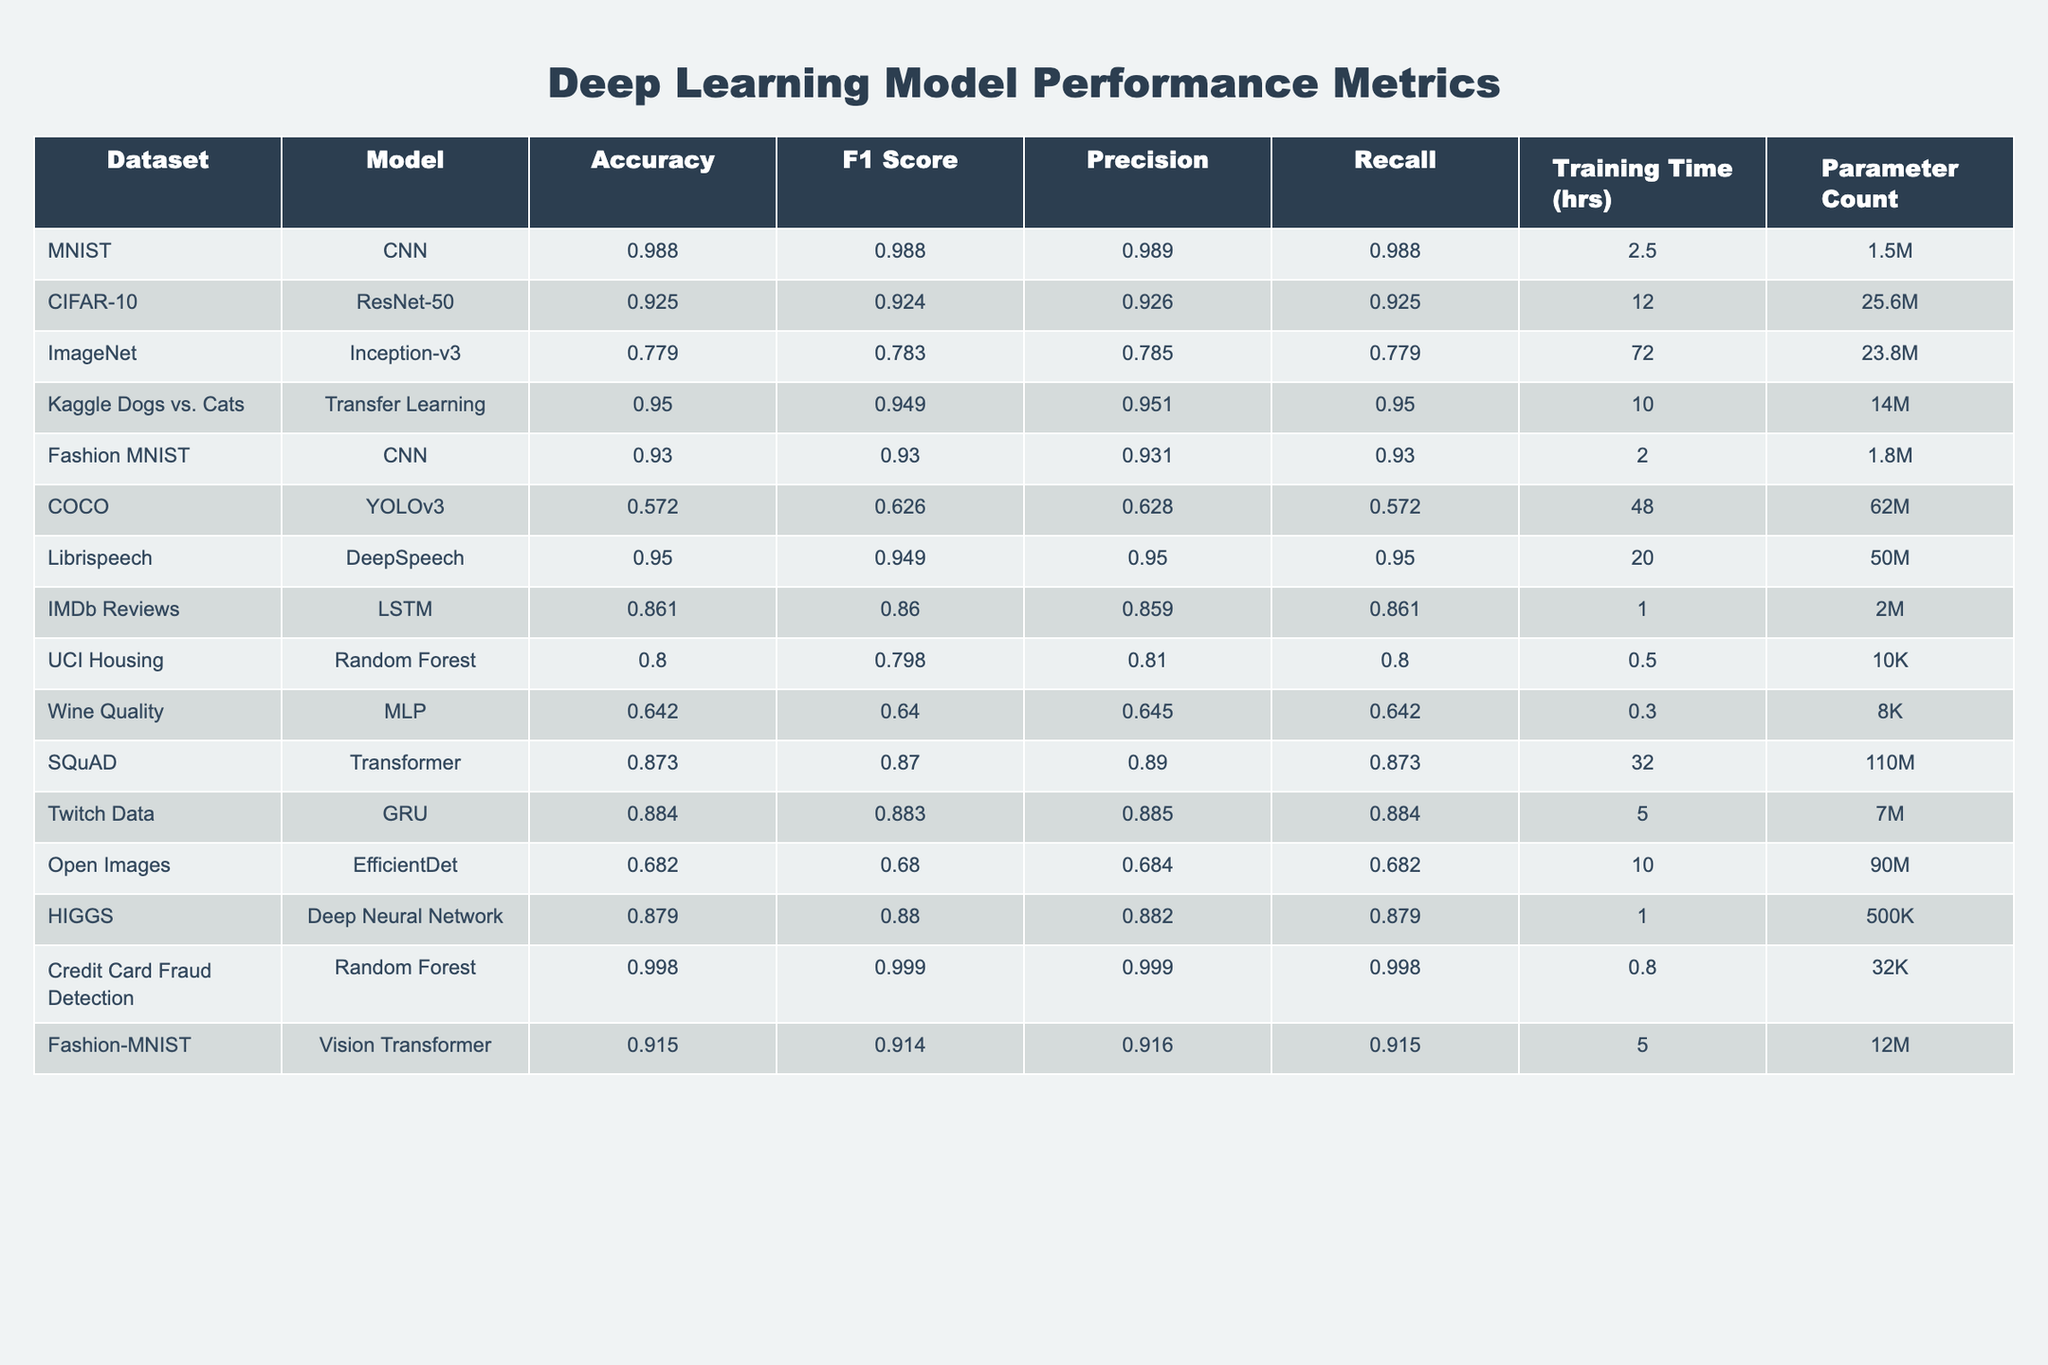What is the accuracy of the CNN model on the MNIST dataset? The table lists the MNIST dataset in the first row, where the CNN model has an accuracy value of 0.988.
Answer: 0.988 Which model has the highest F1 Score? The F1 Score is a metric found in the table; looking through the rows, the Random Forest model used for Credit Card Fraud Detection has the highest F1 Score of 0.999.
Answer: 0.999 What is the average training time of the models listed? To find the average training time, I sum the training times (2.5 + 12 + 72 + 10 + 2 + 48 + 20 + 1 + 0.5 + 0.3 + 32 + 5 + 10 + 1) =  0.3 + 1 + 0.5 + 2 + 5 + 10 + 12 + 20 + 32 + 48 + 72 =  221.6 hours, and then divide by the number of models (14), giving an average of  221.6 / 14 = 15.83 hours.
Answer: 15.83 hours Is the Recall of the YOLOv3 model greater than 0.5? Looking at the table, the Recall for YOLOv3 is 0.572, which is greater than 0.5.
Answer: Yes What is the parameter count of the most complex model in the table? The complexity can be inferred from the Parameter Count column; the model with the highest count is the COCO model (YOLOv3) with 62M parameters.
Answer: 62M How many datasets have an accuracy above 0.9? By reviewing the Accuracy column, we find the models with accuracy above 0.9 are MNIST, Kaggle Dogs vs. Cats, Librispeech, Credit Card Fraud Detection, CNN on Fashion-MNIST, and Transfer Learning for CIFAR-10, giving a total of 6 datasets.
Answer: 6 Which model had the lowest accuracy and what was that accuracy? The table indicates that the model with the lowest accuracy is the YOLOv3 on COCO dataset, with an accuracy of 0.572.
Answer: 0.572 Are there any models that have the same precision score? Checking the Precision column, the models with matching Precision scores are the CNN on Fashion MNIST and the Transfer Learning model both at 0.931, indicating there are two models with the same score.
Answer: Yes What is the difference in accuracy between the model with the highest accuracy and the model with the lowest accuracy? The highest accuracy is 0.998 for the Random Forest model on Credit Card Fraud Detection, and the lowest is 0.572 for YOLOv3 on COCO. The difference is 0.998 - 0.572 = 0.426.
Answer: 0.426 Which models had a training time less than 5 hours? By scanning the Training Time column, the models with training times less than 5 hours are MNIST (2.5), Fashion MNIST (2), IMDb Reviews (1), UCI Housing (0.5), and Wine Quality (0.3), totaling 5 models.
Answer: 5 